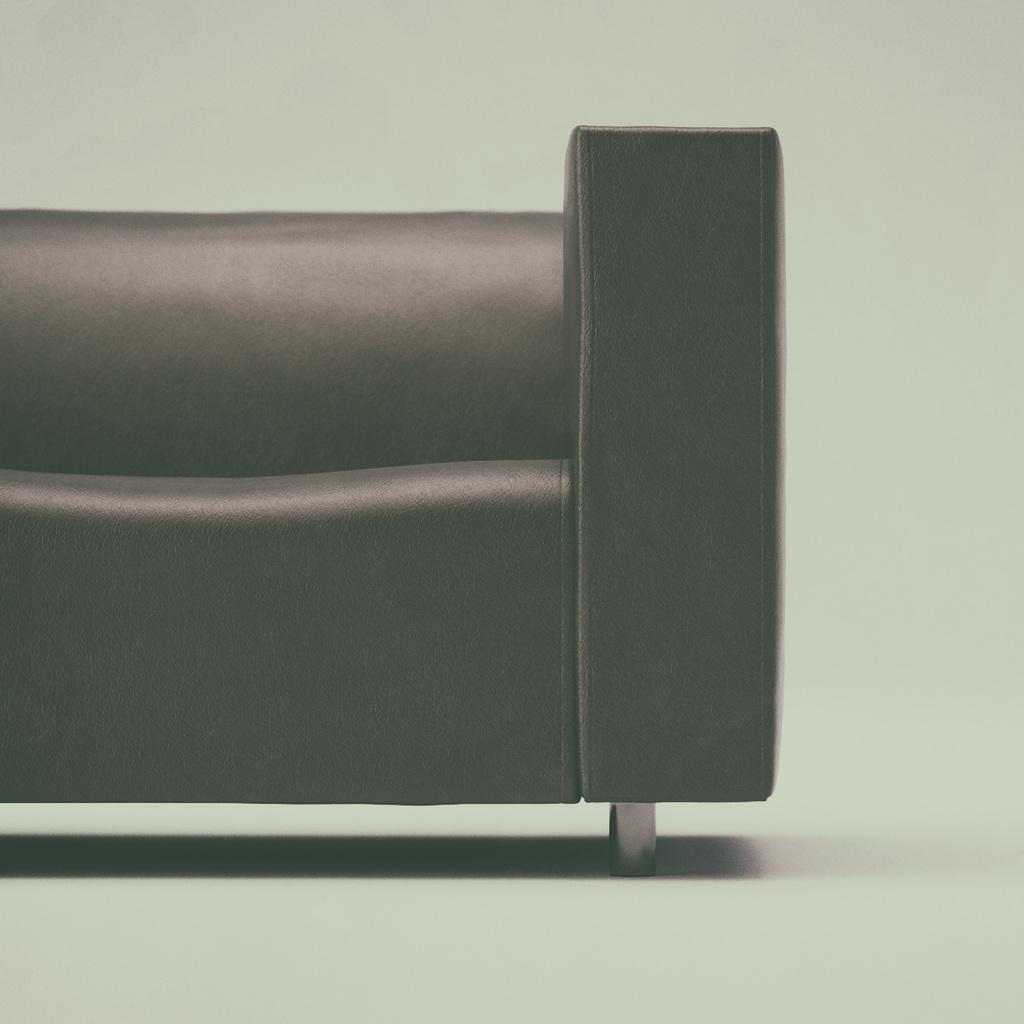How would you summarize this image in a sentence or two? There is a black colour sofa on the floor. 